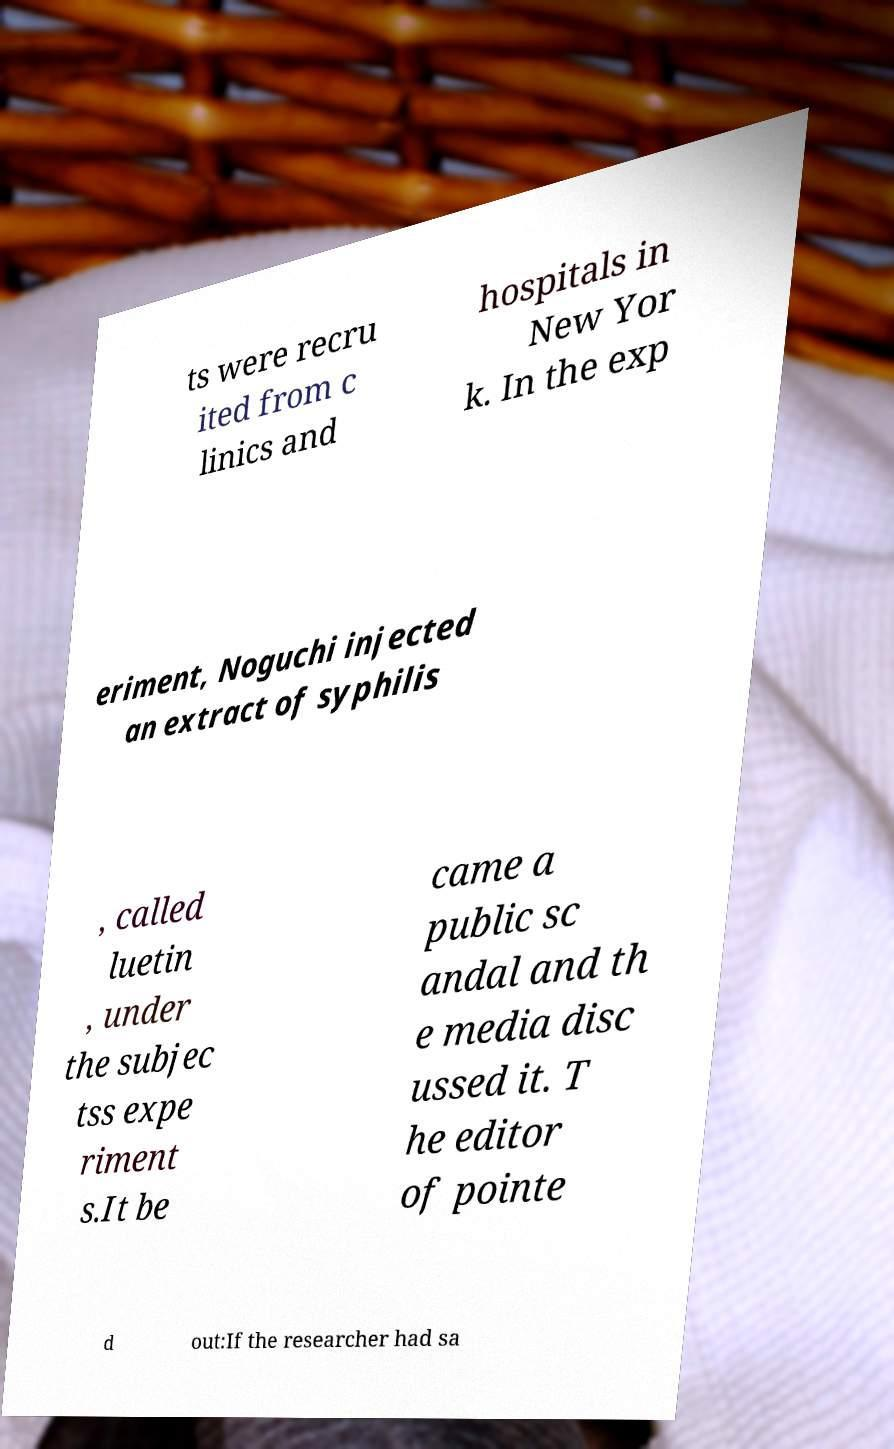I need the written content from this picture converted into text. Can you do that? ts were recru ited from c linics and hospitals in New Yor k. In the exp eriment, Noguchi injected an extract of syphilis , called luetin , under the subjec tss expe riment s.It be came a public sc andal and th e media disc ussed it. T he editor of pointe d out:If the researcher had sa 